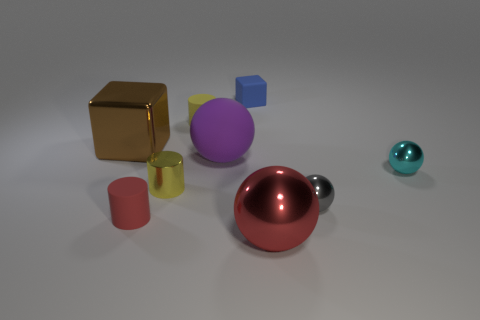Subtract all gray balls. How many yellow cylinders are left? 2 Subtract 1 cylinders. How many cylinders are left? 2 Subtract all small cyan spheres. How many spheres are left? 3 Subtract all gray balls. How many balls are left? 3 Add 1 green blocks. How many objects exist? 10 Subtract all green balls. Subtract all purple blocks. How many balls are left? 4 Subtract all spheres. How many objects are left? 5 Subtract 0 purple cylinders. How many objects are left? 9 Subtract all small brown cylinders. Subtract all tiny balls. How many objects are left? 7 Add 2 blocks. How many blocks are left? 4 